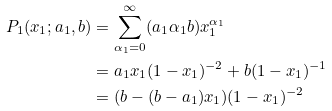<formula> <loc_0><loc_0><loc_500><loc_500>P _ { 1 } ( x _ { 1 } ; a _ { 1 } , b ) & = \sum _ { \alpha _ { 1 } = 0 } ^ { \infty } ( a _ { 1 } \alpha _ { 1 } b ) x _ { 1 } ^ { \alpha _ { 1 } } \\ & = a _ { 1 } x _ { 1 } ( 1 - x _ { 1 } ) ^ { - 2 } + b ( 1 - x _ { 1 } ) ^ { - 1 } \\ & = ( b - ( b - a _ { 1 } ) x _ { 1 } ) ( 1 - x _ { 1 } ) ^ { - 2 }</formula> 